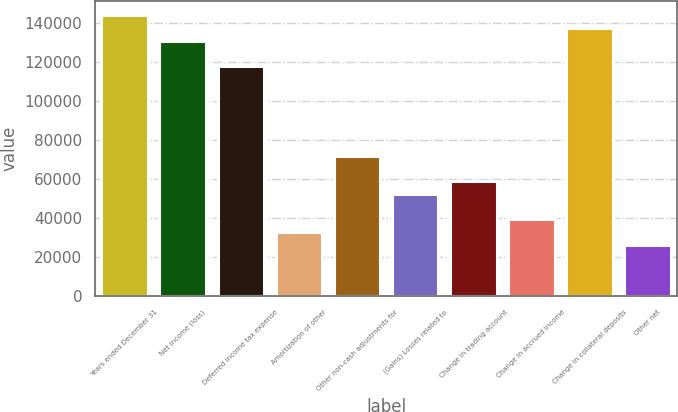Convert chart to OTSL. <chart><loc_0><loc_0><loc_500><loc_500><bar_chart><fcel>Years ended December 31<fcel>Net income (loss)<fcel>Deferred income tax expense<fcel>Amortization of other<fcel>Other non-cash adjustments for<fcel>(Gains) Losses related to<fcel>Change in trading account<fcel>Change in accrued income<fcel>Change in collateral deposits<fcel>Other net<nl><fcel>144055<fcel>130960<fcel>117865<fcel>32747.5<fcel>72032.5<fcel>52390<fcel>58937.5<fcel>39295<fcel>137508<fcel>26200<nl></chart> 